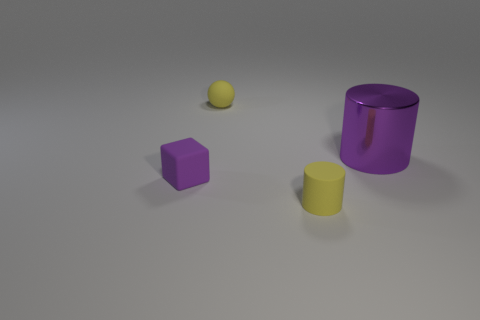Add 4 large purple things. How many objects exist? 8 Subtract all cubes. How many objects are left? 3 Subtract all gray cylinders. Subtract all gray balls. How many cylinders are left? 2 Subtract all small objects. Subtract all big purple cylinders. How many objects are left? 0 Add 2 big metal things. How many big metal things are left? 3 Add 2 large gray metal cylinders. How many large gray metal cylinders exist? 2 Subtract 0 purple balls. How many objects are left? 4 